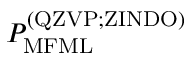<formula> <loc_0><loc_0><loc_500><loc_500>P _ { M F M L } ^ { ( Q Z V P ; Z I N D O ) }</formula> 